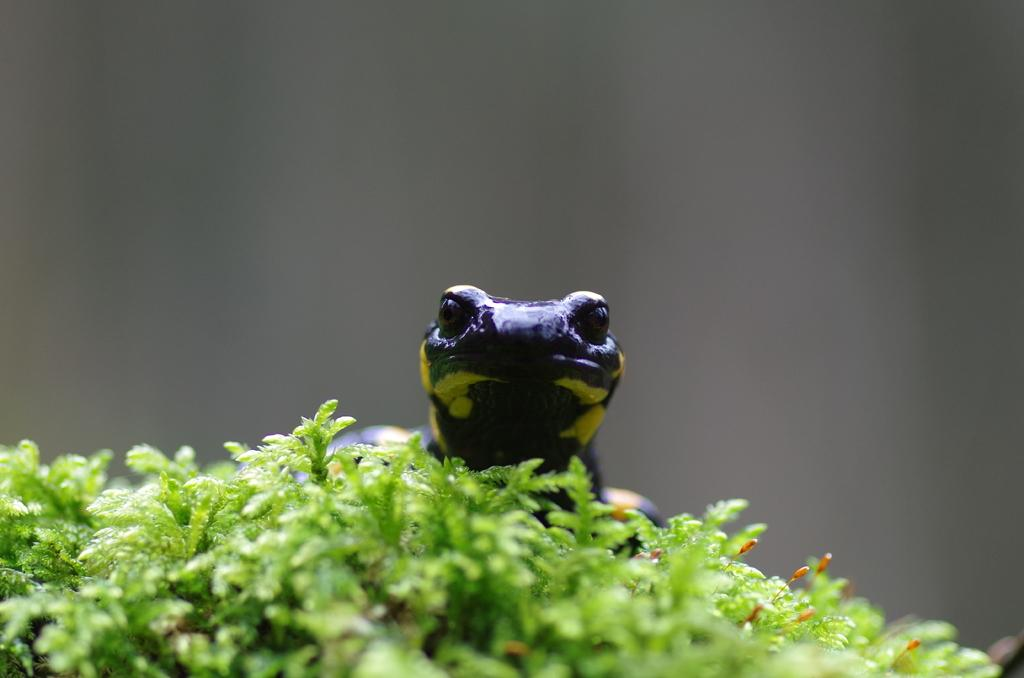What is located in the center of the image? There are plants and a reptile in the center of the image. Can you describe the reptile in the image? The reptile is green and black in color. How is the background of the image depicted? The background of the image is blurred. What type of lamp can be seen in the image? There is no lamp present in the image. Can you describe the deer in the image? There is no deer present in the image. 